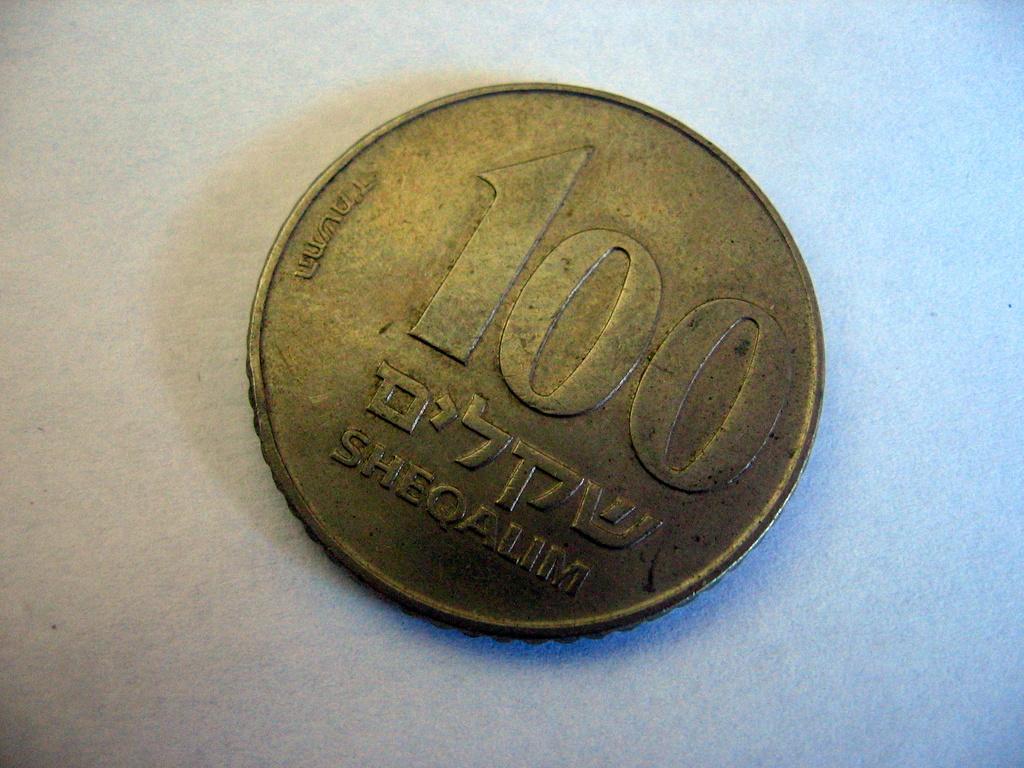What is the stamped numeral on the coin?
Your answer should be compact. 100. What is written across the bottom of the coin?
Your answer should be compact. Sheqalim. 